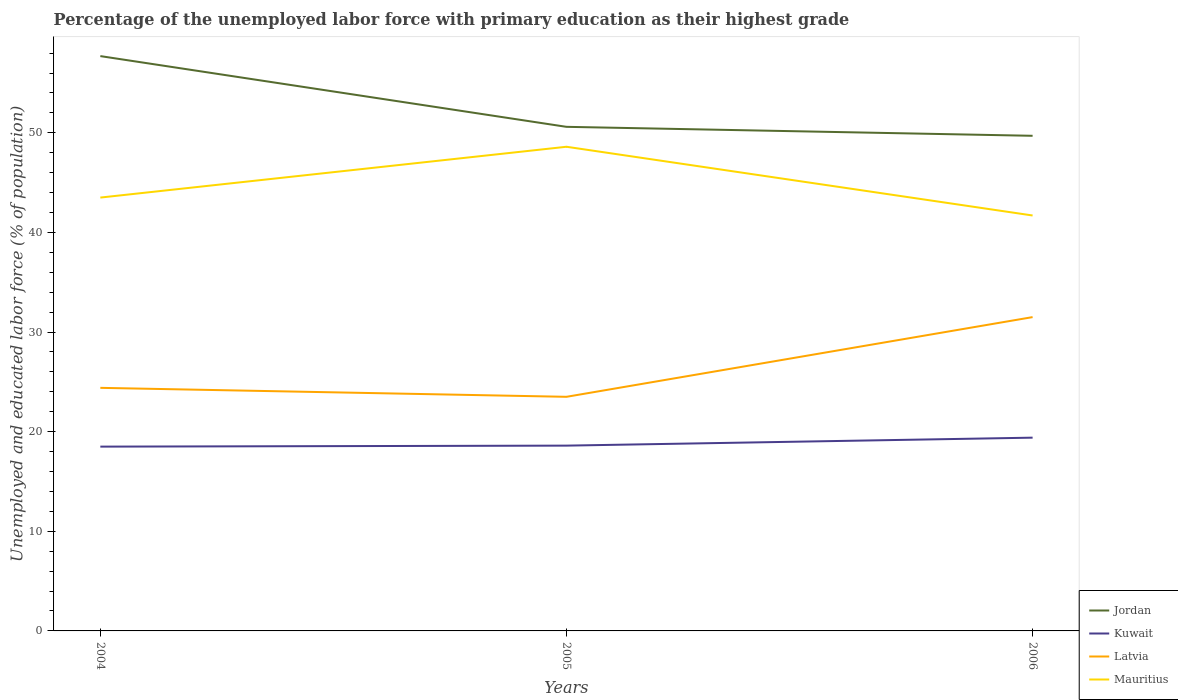Across all years, what is the maximum percentage of the unemployed labor force with primary education in Kuwait?
Your answer should be very brief. 18.5. In which year was the percentage of the unemployed labor force with primary education in Latvia maximum?
Offer a very short reply. 2005. What is the total percentage of the unemployed labor force with primary education in Latvia in the graph?
Offer a very short reply. -7.1. What is the difference between the highest and the second highest percentage of the unemployed labor force with primary education in Latvia?
Your answer should be compact. 8. How many lines are there?
Provide a succinct answer. 4. How many years are there in the graph?
Keep it short and to the point. 3. Where does the legend appear in the graph?
Keep it short and to the point. Bottom right. How many legend labels are there?
Give a very brief answer. 4. How are the legend labels stacked?
Give a very brief answer. Vertical. What is the title of the graph?
Make the answer very short. Percentage of the unemployed labor force with primary education as their highest grade. Does "Uruguay" appear as one of the legend labels in the graph?
Make the answer very short. No. What is the label or title of the Y-axis?
Provide a succinct answer. Unemployed and educated labor force (% of population). What is the Unemployed and educated labor force (% of population) in Jordan in 2004?
Offer a terse response. 57.7. What is the Unemployed and educated labor force (% of population) of Latvia in 2004?
Provide a succinct answer. 24.4. What is the Unemployed and educated labor force (% of population) in Mauritius in 2004?
Your answer should be very brief. 43.5. What is the Unemployed and educated labor force (% of population) in Jordan in 2005?
Offer a very short reply. 50.6. What is the Unemployed and educated labor force (% of population) of Kuwait in 2005?
Offer a terse response. 18.6. What is the Unemployed and educated labor force (% of population) of Latvia in 2005?
Keep it short and to the point. 23.5. What is the Unemployed and educated labor force (% of population) of Mauritius in 2005?
Ensure brevity in your answer.  48.6. What is the Unemployed and educated labor force (% of population) in Jordan in 2006?
Provide a succinct answer. 49.7. What is the Unemployed and educated labor force (% of population) of Kuwait in 2006?
Provide a succinct answer. 19.4. What is the Unemployed and educated labor force (% of population) of Latvia in 2006?
Provide a succinct answer. 31.5. What is the Unemployed and educated labor force (% of population) of Mauritius in 2006?
Your answer should be compact. 41.7. Across all years, what is the maximum Unemployed and educated labor force (% of population) of Jordan?
Offer a terse response. 57.7. Across all years, what is the maximum Unemployed and educated labor force (% of population) in Kuwait?
Your answer should be very brief. 19.4. Across all years, what is the maximum Unemployed and educated labor force (% of population) in Latvia?
Your answer should be compact. 31.5. Across all years, what is the maximum Unemployed and educated labor force (% of population) in Mauritius?
Provide a short and direct response. 48.6. Across all years, what is the minimum Unemployed and educated labor force (% of population) of Jordan?
Your answer should be compact. 49.7. Across all years, what is the minimum Unemployed and educated labor force (% of population) of Latvia?
Offer a very short reply. 23.5. Across all years, what is the minimum Unemployed and educated labor force (% of population) of Mauritius?
Your response must be concise. 41.7. What is the total Unemployed and educated labor force (% of population) in Jordan in the graph?
Give a very brief answer. 158. What is the total Unemployed and educated labor force (% of population) in Kuwait in the graph?
Ensure brevity in your answer.  56.5. What is the total Unemployed and educated labor force (% of population) in Latvia in the graph?
Provide a short and direct response. 79.4. What is the total Unemployed and educated labor force (% of population) of Mauritius in the graph?
Make the answer very short. 133.8. What is the difference between the Unemployed and educated labor force (% of population) in Latvia in 2004 and that in 2005?
Your answer should be very brief. 0.9. What is the difference between the Unemployed and educated labor force (% of population) of Kuwait in 2004 and that in 2006?
Give a very brief answer. -0.9. What is the difference between the Unemployed and educated labor force (% of population) of Mauritius in 2004 and that in 2006?
Keep it short and to the point. 1.8. What is the difference between the Unemployed and educated labor force (% of population) in Kuwait in 2005 and that in 2006?
Provide a short and direct response. -0.8. What is the difference between the Unemployed and educated labor force (% of population) of Latvia in 2005 and that in 2006?
Offer a terse response. -8. What is the difference between the Unemployed and educated labor force (% of population) of Jordan in 2004 and the Unemployed and educated labor force (% of population) of Kuwait in 2005?
Make the answer very short. 39.1. What is the difference between the Unemployed and educated labor force (% of population) of Jordan in 2004 and the Unemployed and educated labor force (% of population) of Latvia in 2005?
Give a very brief answer. 34.2. What is the difference between the Unemployed and educated labor force (% of population) of Kuwait in 2004 and the Unemployed and educated labor force (% of population) of Latvia in 2005?
Provide a succinct answer. -5. What is the difference between the Unemployed and educated labor force (% of population) of Kuwait in 2004 and the Unemployed and educated labor force (% of population) of Mauritius in 2005?
Your answer should be very brief. -30.1. What is the difference between the Unemployed and educated labor force (% of population) of Latvia in 2004 and the Unemployed and educated labor force (% of population) of Mauritius in 2005?
Provide a short and direct response. -24.2. What is the difference between the Unemployed and educated labor force (% of population) of Jordan in 2004 and the Unemployed and educated labor force (% of population) of Kuwait in 2006?
Provide a short and direct response. 38.3. What is the difference between the Unemployed and educated labor force (% of population) of Jordan in 2004 and the Unemployed and educated labor force (% of population) of Latvia in 2006?
Provide a succinct answer. 26.2. What is the difference between the Unemployed and educated labor force (% of population) in Jordan in 2004 and the Unemployed and educated labor force (% of population) in Mauritius in 2006?
Your response must be concise. 16. What is the difference between the Unemployed and educated labor force (% of population) in Kuwait in 2004 and the Unemployed and educated labor force (% of population) in Mauritius in 2006?
Keep it short and to the point. -23.2. What is the difference between the Unemployed and educated labor force (% of population) of Latvia in 2004 and the Unemployed and educated labor force (% of population) of Mauritius in 2006?
Provide a short and direct response. -17.3. What is the difference between the Unemployed and educated labor force (% of population) in Jordan in 2005 and the Unemployed and educated labor force (% of population) in Kuwait in 2006?
Ensure brevity in your answer.  31.2. What is the difference between the Unemployed and educated labor force (% of population) in Jordan in 2005 and the Unemployed and educated labor force (% of population) in Latvia in 2006?
Ensure brevity in your answer.  19.1. What is the difference between the Unemployed and educated labor force (% of population) of Jordan in 2005 and the Unemployed and educated labor force (% of population) of Mauritius in 2006?
Provide a short and direct response. 8.9. What is the difference between the Unemployed and educated labor force (% of population) of Kuwait in 2005 and the Unemployed and educated labor force (% of population) of Mauritius in 2006?
Offer a terse response. -23.1. What is the difference between the Unemployed and educated labor force (% of population) of Latvia in 2005 and the Unemployed and educated labor force (% of population) of Mauritius in 2006?
Provide a succinct answer. -18.2. What is the average Unemployed and educated labor force (% of population) of Jordan per year?
Offer a very short reply. 52.67. What is the average Unemployed and educated labor force (% of population) in Kuwait per year?
Ensure brevity in your answer.  18.83. What is the average Unemployed and educated labor force (% of population) in Latvia per year?
Keep it short and to the point. 26.47. What is the average Unemployed and educated labor force (% of population) in Mauritius per year?
Keep it short and to the point. 44.6. In the year 2004, what is the difference between the Unemployed and educated labor force (% of population) of Jordan and Unemployed and educated labor force (% of population) of Kuwait?
Ensure brevity in your answer.  39.2. In the year 2004, what is the difference between the Unemployed and educated labor force (% of population) of Jordan and Unemployed and educated labor force (% of population) of Latvia?
Make the answer very short. 33.3. In the year 2004, what is the difference between the Unemployed and educated labor force (% of population) of Latvia and Unemployed and educated labor force (% of population) of Mauritius?
Give a very brief answer. -19.1. In the year 2005, what is the difference between the Unemployed and educated labor force (% of population) in Jordan and Unemployed and educated labor force (% of population) in Latvia?
Ensure brevity in your answer.  27.1. In the year 2005, what is the difference between the Unemployed and educated labor force (% of population) in Jordan and Unemployed and educated labor force (% of population) in Mauritius?
Offer a very short reply. 2. In the year 2005, what is the difference between the Unemployed and educated labor force (% of population) of Kuwait and Unemployed and educated labor force (% of population) of Latvia?
Offer a very short reply. -4.9. In the year 2005, what is the difference between the Unemployed and educated labor force (% of population) in Kuwait and Unemployed and educated labor force (% of population) in Mauritius?
Your answer should be very brief. -30. In the year 2005, what is the difference between the Unemployed and educated labor force (% of population) of Latvia and Unemployed and educated labor force (% of population) of Mauritius?
Offer a terse response. -25.1. In the year 2006, what is the difference between the Unemployed and educated labor force (% of population) of Jordan and Unemployed and educated labor force (% of population) of Kuwait?
Provide a short and direct response. 30.3. In the year 2006, what is the difference between the Unemployed and educated labor force (% of population) in Jordan and Unemployed and educated labor force (% of population) in Latvia?
Offer a very short reply. 18.2. In the year 2006, what is the difference between the Unemployed and educated labor force (% of population) in Kuwait and Unemployed and educated labor force (% of population) in Mauritius?
Make the answer very short. -22.3. In the year 2006, what is the difference between the Unemployed and educated labor force (% of population) of Latvia and Unemployed and educated labor force (% of population) of Mauritius?
Keep it short and to the point. -10.2. What is the ratio of the Unemployed and educated labor force (% of population) in Jordan in 2004 to that in 2005?
Provide a succinct answer. 1.14. What is the ratio of the Unemployed and educated labor force (% of population) in Latvia in 2004 to that in 2005?
Provide a short and direct response. 1.04. What is the ratio of the Unemployed and educated labor force (% of population) of Mauritius in 2004 to that in 2005?
Offer a very short reply. 0.9. What is the ratio of the Unemployed and educated labor force (% of population) in Jordan in 2004 to that in 2006?
Provide a short and direct response. 1.16. What is the ratio of the Unemployed and educated labor force (% of population) in Kuwait in 2004 to that in 2006?
Give a very brief answer. 0.95. What is the ratio of the Unemployed and educated labor force (% of population) in Latvia in 2004 to that in 2006?
Make the answer very short. 0.77. What is the ratio of the Unemployed and educated labor force (% of population) of Mauritius in 2004 to that in 2006?
Make the answer very short. 1.04. What is the ratio of the Unemployed and educated labor force (% of population) in Jordan in 2005 to that in 2006?
Give a very brief answer. 1.02. What is the ratio of the Unemployed and educated labor force (% of population) in Kuwait in 2005 to that in 2006?
Provide a succinct answer. 0.96. What is the ratio of the Unemployed and educated labor force (% of population) of Latvia in 2005 to that in 2006?
Make the answer very short. 0.75. What is the ratio of the Unemployed and educated labor force (% of population) of Mauritius in 2005 to that in 2006?
Your answer should be very brief. 1.17. What is the difference between the highest and the second highest Unemployed and educated labor force (% of population) of Mauritius?
Keep it short and to the point. 5.1. What is the difference between the highest and the lowest Unemployed and educated labor force (% of population) of Jordan?
Give a very brief answer. 8. What is the difference between the highest and the lowest Unemployed and educated labor force (% of population) of Kuwait?
Provide a short and direct response. 0.9. What is the difference between the highest and the lowest Unemployed and educated labor force (% of population) of Latvia?
Offer a very short reply. 8. 